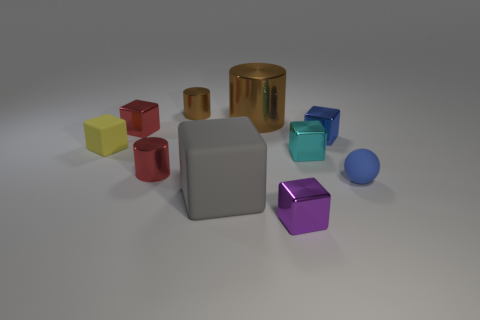There is a brown metallic thing that is on the right side of the big object that is in front of the small red metal object in front of the tiny blue block; what size is it?
Keep it short and to the point. Large. There is a cube that is the same color as the ball; what size is it?
Provide a short and direct response. Small. How many things are small cylinders or big cyan metal objects?
Your answer should be very brief. 2. What shape is the metal thing that is both to the left of the large rubber thing and on the right side of the red cylinder?
Your answer should be compact. Cylinder. There is a gray matte object; does it have the same shape as the small rubber thing right of the tiny purple metal cube?
Offer a very short reply. No. There is a tiny yellow thing; are there any yellow matte things on the left side of it?
Make the answer very short. No. What is the material of the thing that is the same color as the tiny ball?
Offer a very short reply. Metal. What number of spheres are brown metallic objects or large brown shiny things?
Your answer should be very brief. 0. Is the shape of the purple shiny thing the same as the large matte object?
Offer a very short reply. Yes. There is a metal thing in front of the small sphere; what is its size?
Keep it short and to the point. Small. 